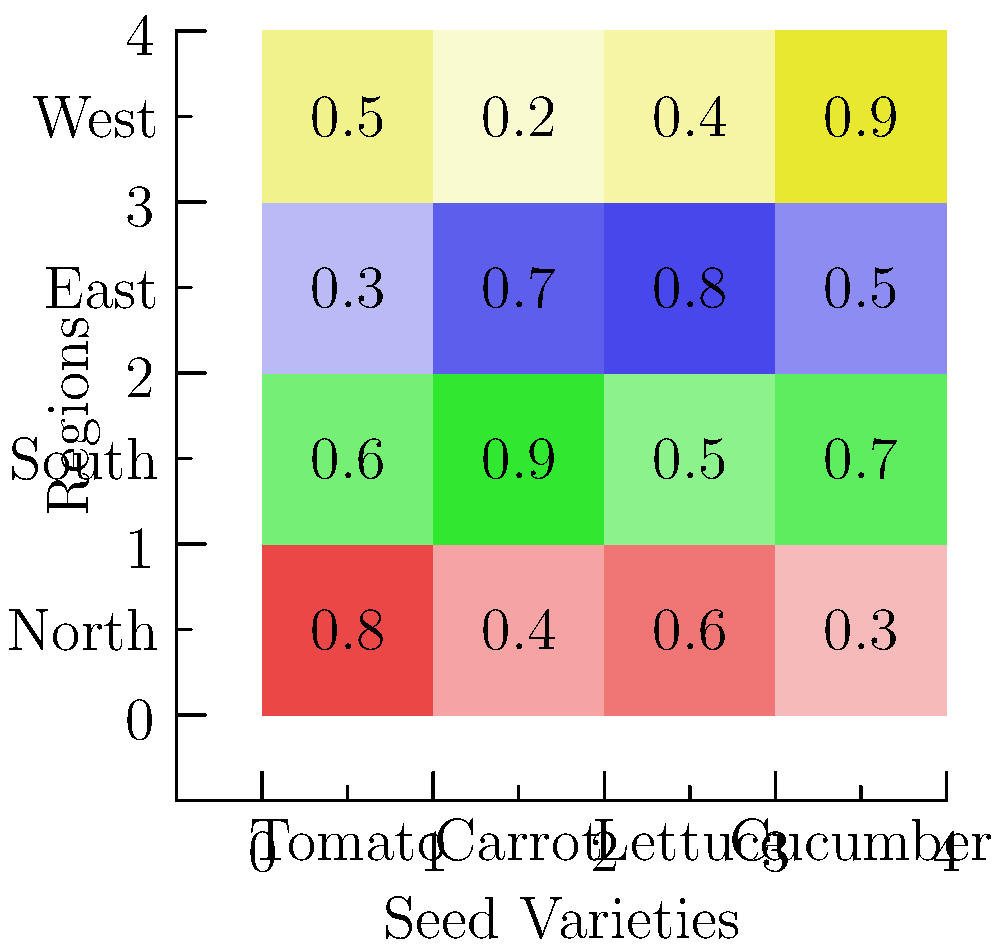Based on the heat map showing seed variety popularity across different regions, which seed variety has the highest overall popularity (sum of popularity scores across all regions), and in which region is it most popular? To solve this problem, we need to follow these steps:

1. Calculate the sum of popularity scores for each seed variety across all regions:
   
   Tomato: $0.8 + 0.4 + 0.6 + 0.3 = 2.1$
   Carrot: $0.6 + 0.9 + 0.5 + 0.7 = 2.7$
   Lettuce: $0.3 + 0.7 + 0.8 + 0.5 = 2.3$
   Cucumber: $0.5 + 0.2 + 0.4 + 0.9 = 2.0$

2. Identify the seed variety with the highest overall popularity:
   Carrot has the highest sum at 2.7.

3. For the Carrot seed variety, find the region with the highest popularity score:
   North: 0.6
   South: 0.9
   East: 0.5
   West: 0.7

   The highest score for Carrot is 0.9 in the South region.
Answer: Carrot; South 